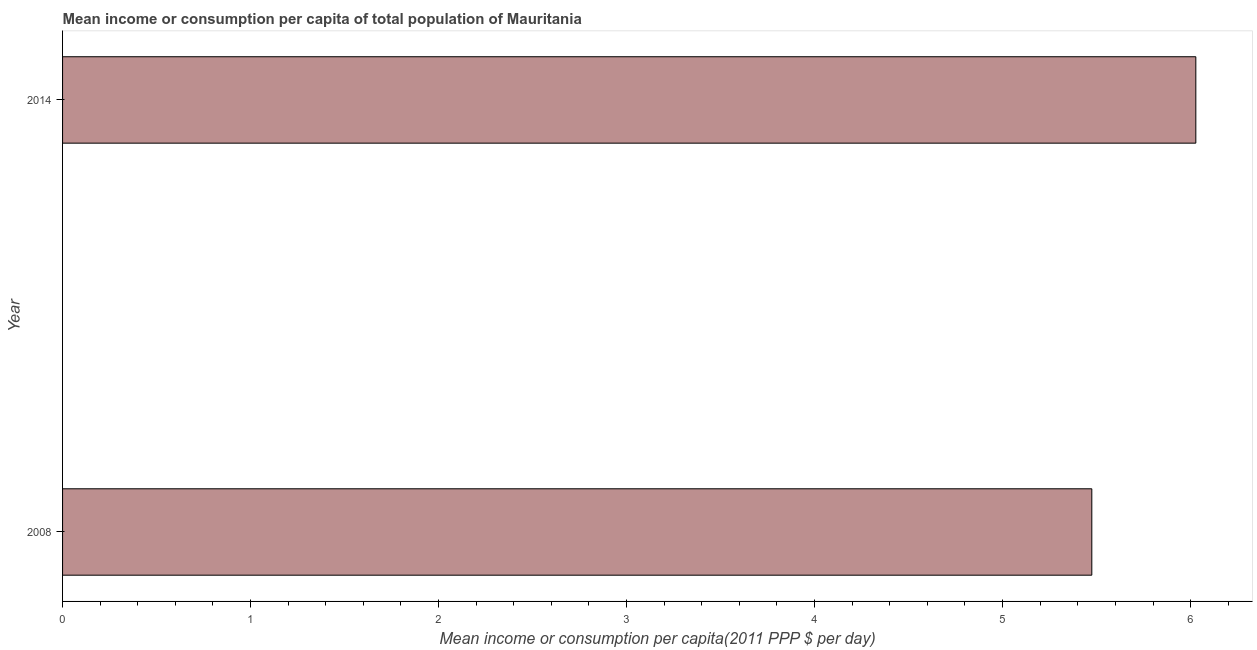Does the graph contain any zero values?
Give a very brief answer. No. Does the graph contain grids?
Ensure brevity in your answer.  No. What is the title of the graph?
Offer a very short reply. Mean income or consumption per capita of total population of Mauritania. What is the label or title of the X-axis?
Offer a terse response. Mean income or consumption per capita(2011 PPP $ per day). What is the mean income or consumption in 2014?
Give a very brief answer. 6.03. Across all years, what is the maximum mean income or consumption?
Give a very brief answer. 6.03. Across all years, what is the minimum mean income or consumption?
Give a very brief answer. 5.47. In which year was the mean income or consumption maximum?
Provide a short and direct response. 2014. In which year was the mean income or consumption minimum?
Give a very brief answer. 2008. What is the sum of the mean income or consumption?
Make the answer very short. 11.5. What is the difference between the mean income or consumption in 2008 and 2014?
Keep it short and to the point. -0.55. What is the average mean income or consumption per year?
Keep it short and to the point. 5.75. What is the median mean income or consumption?
Provide a succinct answer. 5.75. In how many years, is the mean income or consumption greater than 4.6 $?
Provide a short and direct response. 2. What is the ratio of the mean income or consumption in 2008 to that in 2014?
Your answer should be very brief. 0.91. In how many years, is the mean income or consumption greater than the average mean income or consumption taken over all years?
Make the answer very short. 1. How many bars are there?
Your answer should be compact. 2. How many years are there in the graph?
Ensure brevity in your answer.  2. What is the difference between two consecutive major ticks on the X-axis?
Offer a very short reply. 1. Are the values on the major ticks of X-axis written in scientific E-notation?
Ensure brevity in your answer.  No. What is the Mean income or consumption per capita(2011 PPP $ per day) in 2008?
Provide a short and direct response. 5.47. What is the Mean income or consumption per capita(2011 PPP $ per day) in 2014?
Ensure brevity in your answer.  6.03. What is the difference between the Mean income or consumption per capita(2011 PPP $ per day) in 2008 and 2014?
Ensure brevity in your answer.  -0.55. What is the ratio of the Mean income or consumption per capita(2011 PPP $ per day) in 2008 to that in 2014?
Your response must be concise. 0.91. 